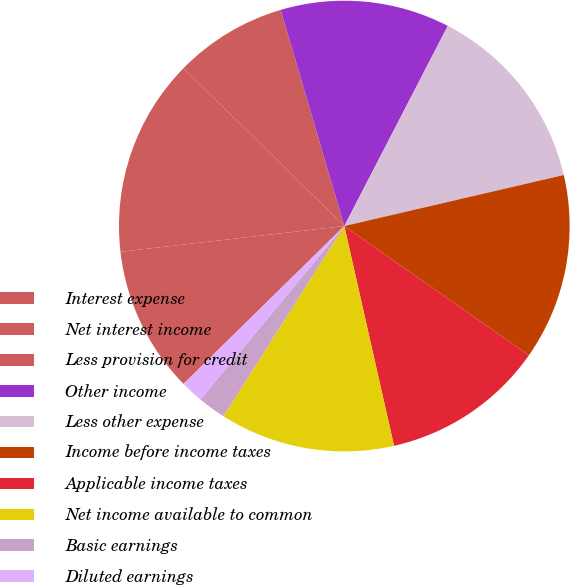<chart> <loc_0><loc_0><loc_500><loc_500><pie_chart><fcel>Interest expense<fcel>Net interest income<fcel>Less provision for credit<fcel>Other income<fcel>Less other expense<fcel>Income before income taxes<fcel>Applicable income taxes<fcel>Net income available to common<fcel>Basic earnings<fcel>Diluted earnings<nl><fcel>10.53%<fcel>14.17%<fcel>8.1%<fcel>12.15%<fcel>13.77%<fcel>13.36%<fcel>11.74%<fcel>12.55%<fcel>2.02%<fcel>1.62%<nl></chart> 